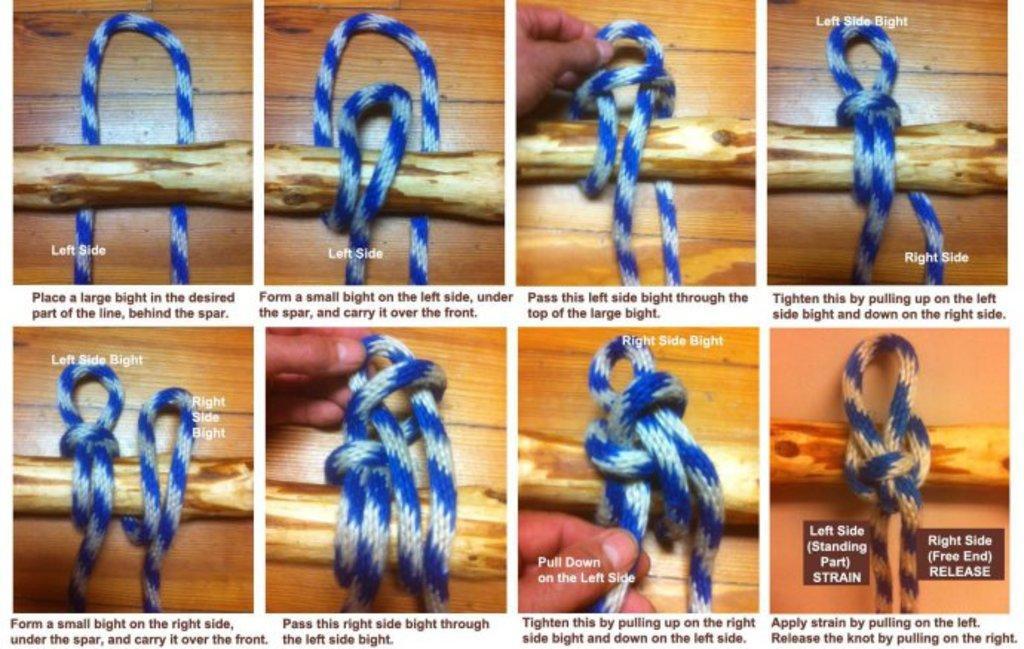Describe this image in one or two sentences. This is a collage image in this picture, there are eight pictures in all the pictures there is a stick and thread, in three pictures there is a hand and there is some text over the pictures and below the pictures. 